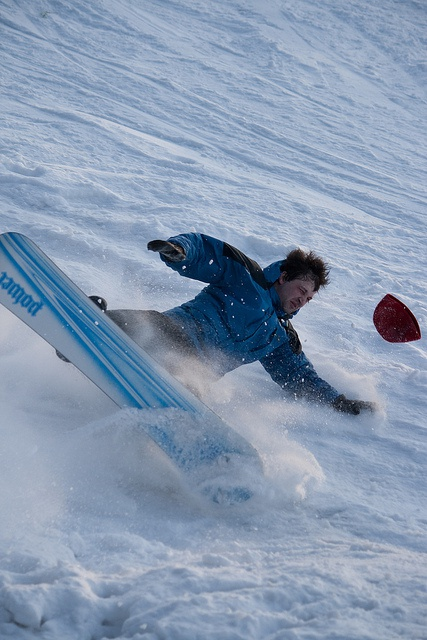Describe the objects in this image and their specific colors. I can see snowboard in gray, teal, and darkgray tones and people in gray, navy, black, and blue tones in this image. 